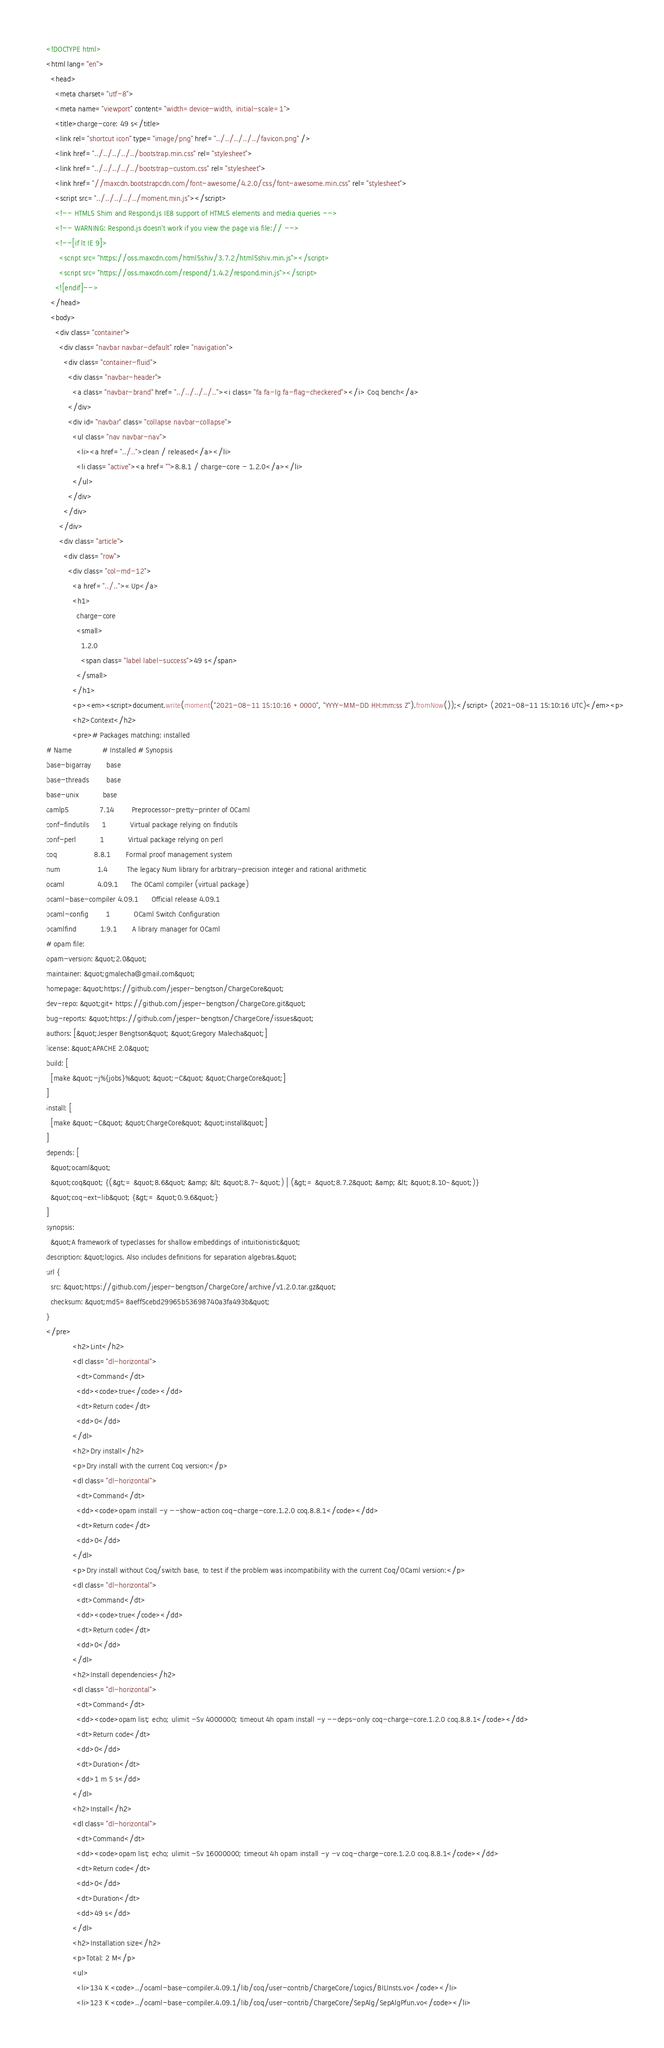Convert code to text. <code><loc_0><loc_0><loc_500><loc_500><_HTML_><!DOCTYPE html>
<html lang="en">
  <head>
    <meta charset="utf-8">
    <meta name="viewport" content="width=device-width, initial-scale=1">
    <title>charge-core: 49 s</title>
    <link rel="shortcut icon" type="image/png" href="../../../../../favicon.png" />
    <link href="../../../../../bootstrap.min.css" rel="stylesheet">
    <link href="../../../../../bootstrap-custom.css" rel="stylesheet">
    <link href="//maxcdn.bootstrapcdn.com/font-awesome/4.2.0/css/font-awesome.min.css" rel="stylesheet">
    <script src="../../../../../moment.min.js"></script>
    <!-- HTML5 Shim and Respond.js IE8 support of HTML5 elements and media queries -->
    <!-- WARNING: Respond.js doesn't work if you view the page via file:// -->
    <!--[if lt IE 9]>
      <script src="https://oss.maxcdn.com/html5shiv/3.7.2/html5shiv.min.js"></script>
      <script src="https://oss.maxcdn.com/respond/1.4.2/respond.min.js"></script>
    <![endif]-->
  </head>
  <body>
    <div class="container">
      <div class="navbar navbar-default" role="navigation">
        <div class="container-fluid">
          <div class="navbar-header">
            <a class="navbar-brand" href="../../../../.."><i class="fa fa-lg fa-flag-checkered"></i> Coq bench</a>
          </div>
          <div id="navbar" class="collapse navbar-collapse">
            <ul class="nav navbar-nav">
              <li><a href="../..">clean / released</a></li>
              <li class="active"><a href="">8.8.1 / charge-core - 1.2.0</a></li>
            </ul>
          </div>
        </div>
      </div>
      <div class="article">
        <div class="row">
          <div class="col-md-12">
            <a href="../..">« Up</a>
            <h1>
              charge-core
              <small>
                1.2.0
                <span class="label label-success">49 s</span>
              </small>
            </h1>
            <p><em><script>document.write(moment("2021-08-11 15:10:16 +0000", "YYYY-MM-DD HH:mm:ss Z").fromNow());</script> (2021-08-11 15:10:16 UTC)</em><p>
            <h2>Context</h2>
            <pre># Packages matching: installed
# Name              # Installed # Synopsis
base-bigarray       base
base-threads        base
base-unix           base
camlp5              7.14        Preprocessor-pretty-printer of OCaml
conf-findutils      1           Virtual package relying on findutils
conf-perl           1           Virtual package relying on perl
coq                 8.8.1       Formal proof management system
num                 1.4         The legacy Num library for arbitrary-precision integer and rational arithmetic
ocaml               4.09.1      The OCaml compiler (virtual package)
ocaml-base-compiler 4.09.1      Official release 4.09.1
ocaml-config        1           OCaml Switch Configuration
ocamlfind           1.9.1       A library manager for OCaml
# opam file:
opam-version: &quot;2.0&quot;
maintainer: &quot;gmalecha@gmail.com&quot;
homepage: &quot;https://github.com/jesper-bengtson/ChargeCore&quot;
dev-repo: &quot;git+https://github.com/jesper-bengtson/ChargeCore.git&quot;
bug-reports: &quot;https://github.com/jesper-bengtson/ChargeCore/issues&quot;
authors: [&quot;Jesper Bengtson&quot; &quot;Gregory Malecha&quot;]
license: &quot;APACHE 2.0&quot;
build: [
  [make &quot;-j%{jobs}%&quot; &quot;-C&quot; &quot;ChargeCore&quot;]
]
install: [
  [make &quot;-C&quot; &quot;ChargeCore&quot; &quot;install&quot;]
]
depends: [
  &quot;ocaml&quot;
  &quot;coq&quot; {(&gt;= &quot;8.6&quot; &amp; &lt; &quot;8.7~&quot;) | (&gt;= &quot;8.7.2&quot; &amp; &lt; &quot;8.10~&quot;)}
  &quot;coq-ext-lib&quot; {&gt;= &quot;0.9.6&quot;}
]
synopsis:
  &quot;A framework of typeclasses for shallow embeddings of intuitionistic&quot;
description: &quot;logics. Also includes definitions for separation algebras.&quot;
url {
  src: &quot;https://github.com/jesper-bengtson/ChargeCore/archive/v1.2.0.tar.gz&quot;
  checksum: &quot;md5=8aeff5cebd29965b53698740a3fa493b&quot;
}
</pre>
            <h2>Lint</h2>
            <dl class="dl-horizontal">
              <dt>Command</dt>
              <dd><code>true</code></dd>
              <dt>Return code</dt>
              <dd>0</dd>
            </dl>
            <h2>Dry install</h2>
            <p>Dry install with the current Coq version:</p>
            <dl class="dl-horizontal">
              <dt>Command</dt>
              <dd><code>opam install -y --show-action coq-charge-core.1.2.0 coq.8.8.1</code></dd>
              <dt>Return code</dt>
              <dd>0</dd>
            </dl>
            <p>Dry install without Coq/switch base, to test if the problem was incompatibility with the current Coq/OCaml version:</p>
            <dl class="dl-horizontal">
              <dt>Command</dt>
              <dd><code>true</code></dd>
              <dt>Return code</dt>
              <dd>0</dd>
            </dl>
            <h2>Install dependencies</h2>
            <dl class="dl-horizontal">
              <dt>Command</dt>
              <dd><code>opam list; echo; ulimit -Sv 4000000; timeout 4h opam install -y --deps-only coq-charge-core.1.2.0 coq.8.8.1</code></dd>
              <dt>Return code</dt>
              <dd>0</dd>
              <dt>Duration</dt>
              <dd>1 m 5 s</dd>
            </dl>
            <h2>Install</h2>
            <dl class="dl-horizontal">
              <dt>Command</dt>
              <dd><code>opam list; echo; ulimit -Sv 16000000; timeout 4h opam install -y -v coq-charge-core.1.2.0 coq.8.8.1</code></dd>
              <dt>Return code</dt>
              <dd>0</dd>
              <dt>Duration</dt>
              <dd>49 s</dd>
            </dl>
            <h2>Installation size</h2>
            <p>Total: 2 M</p>
            <ul>
              <li>134 K <code>../ocaml-base-compiler.4.09.1/lib/coq/user-contrib/ChargeCore/Logics/BILInsts.vo</code></li>
              <li>123 K <code>../ocaml-base-compiler.4.09.1/lib/coq/user-contrib/ChargeCore/SepAlg/SepAlgPfun.vo</code></li></code> 